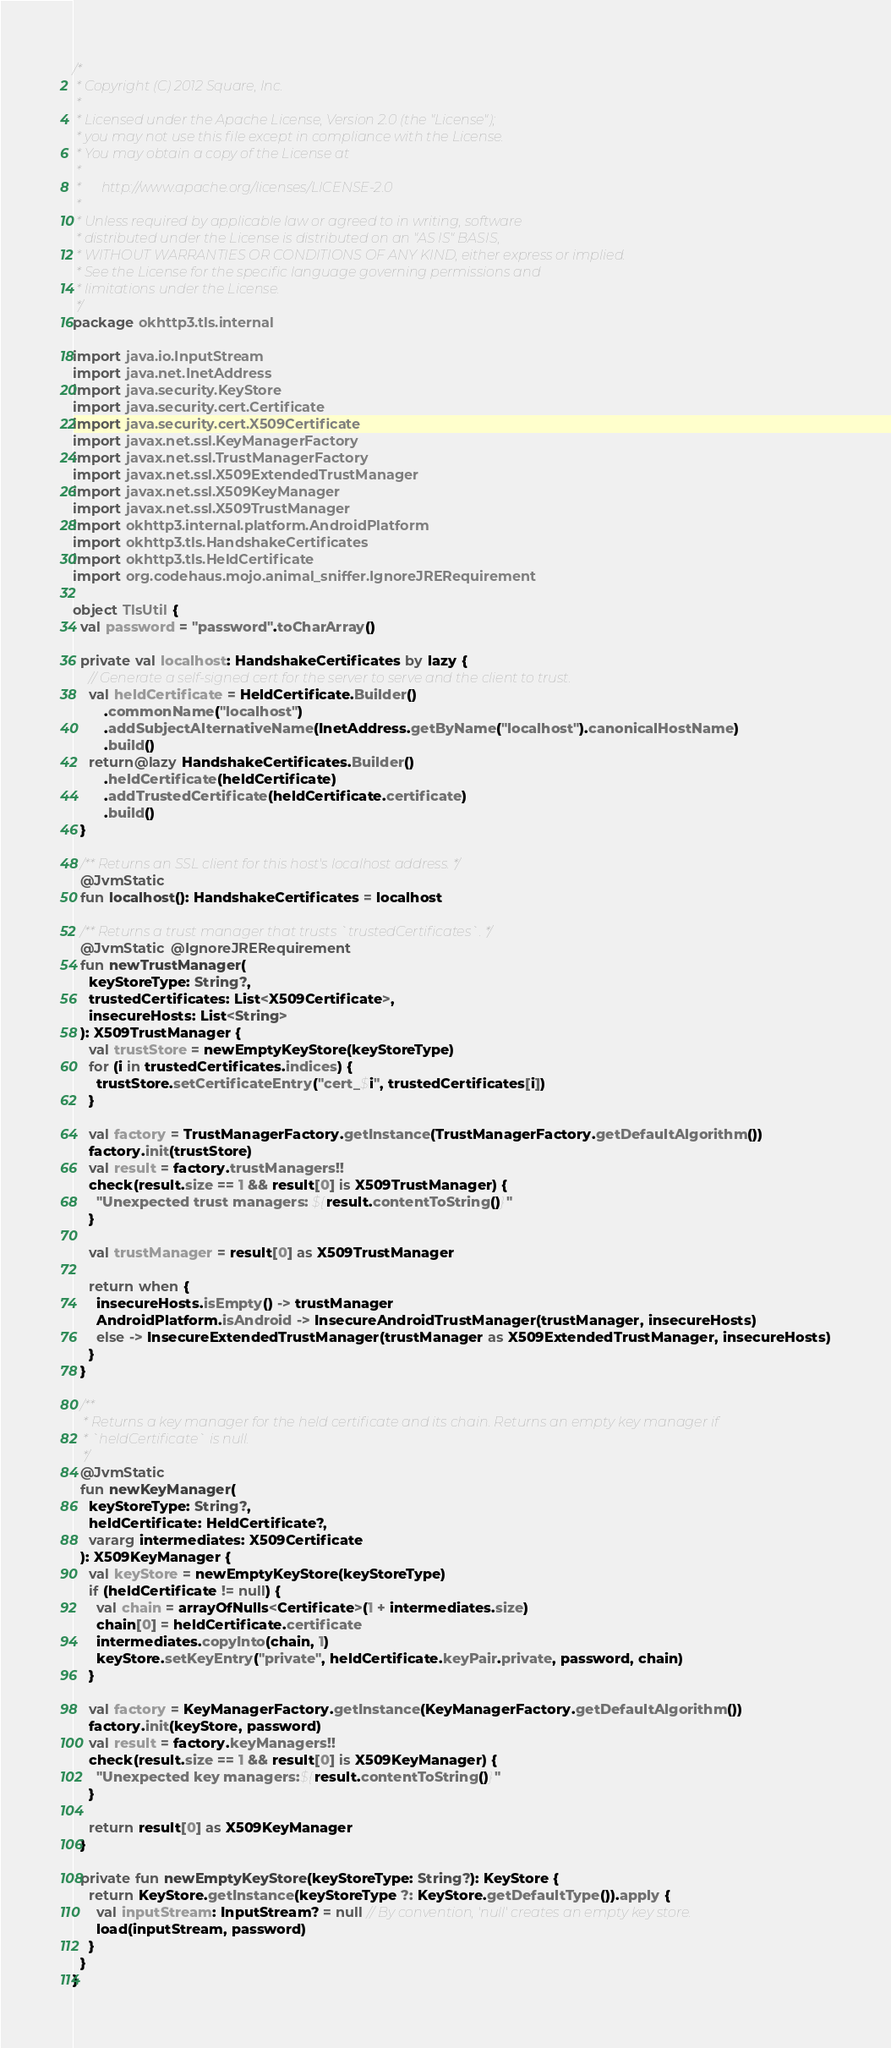<code> <loc_0><loc_0><loc_500><loc_500><_Kotlin_>/*
 * Copyright (C) 2012 Square, Inc.
 *
 * Licensed under the Apache License, Version 2.0 (the "License");
 * you may not use this file except in compliance with the License.
 * You may obtain a copy of the License at
 *
 *      http://www.apache.org/licenses/LICENSE-2.0
 *
 * Unless required by applicable law or agreed to in writing, software
 * distributed under the License is distributed on an "AS IS" BASIS,
 * WITHOUT WARRANTIES OR CONDITIONS OF ANY KIND, either express or implied.
 * See the License for the specific language governing permissions and
 * limitations under the License.
 */
package okhttp3.tls.internal

import java.io.InputStream
import java.net.InetAddress
import java.security.KeyStore
import java.security.cert.Certificate
import java.security.cert.X509Certificate
import javax.net.ssl.KeyManagerFactory
import javax.net.ssl.TrustManagerFactory
import javax.net.ssl.X509ExtendedTrustManager
import javax.net.ssl.X509KeyManager
import javax.net.ssl.X509TrustManager
import okhttp3.internal.platform.AndroidPlatform
import okhttp3.tls.HandshakeCertificates
import okhttp3.tls.HeldCertificate
import org.codehaus.mojo.animal_sniffer.IgnoreJRERequirement

object TlsUtil {
  val password = "password".toCharArray()

  private val localhost: HandshakeCertificates by lazy {
    // Generate a self-signed cert for the server to serve and the client to trust.
    val heldCertificate = HeldCertificate.Builder()
        .commonName("localhost")
        .addSubjectAlternativeName(InetAddress.getByName("localhost").canonicalHostName)
        .build()
    return@lazy HandshakeCertificates.Builder()
        .heldCertificate(heldCertificate)
        .addTrustedCertificate(heldCertificate.certificate)
        .build()
  }

  /** Returns an SSL client for this host's localhost address. */
  @JvmStatic
  fun localhost(): HandshakeCertificates = localhost

  /** Returns a trust manager that trusts `trustedCertificates`. */
  @JvmStatic @IgnoreJRERequirement
  fun newTrustManager(
    keyStoreType: String?,
    trustedCertificates: List<X509Certificate>,
    insecureHosts: List<String>
  ): X509TrustManager {
    val trustStore = newEmptyKeyStore(keyStoreType)
    for (i in trustedCertificates.indices) {
      trustStore.setCertificateEntry("cert_$i", trustedCertificates[i])
    }

    val factory = TrustManagerFactory.getInstance(TrustManagerFactory.getDefaultAlgorithm())
    factory.init(trustStore)
    val result = factory.trustManagers!!
    check(result.size == 1 && result[0] is X509TrustManager) {
      "Unexpected trust managers: ${result.contentToString()}"
    }

    val trustManager = result[0] as X509TrustManager

    return when {
      insecureHosts.isEmpty() -> trustManager
      AndroidPlatform.isAndroid -> InsecureAndroidTrustManager(trustManager, insecureHosts)
      else -> InsecureExtendedTrustManager(trustManager as X509ExtendedTrustManager, insecureHosts)
    }
  }

  /**
   * Returns a key manager for the held certificate and its chain. Returns an empty key manager if
   * `heldCertificate` is null.
   */
  @JvmStatic
  fun newKeyManager(
    keyStoreType: String?,
    heldCertificate: HeldCertificate?,
    vararg intermediates: X509Certificate
  ): X509KeyManager {
    val keyStore = newEmptyKeyStore(keyStoreType)
    if (heldCertificate != null) {
      val chain = arrayOfNulls<Certificate>(1 + intermediates.size)
      chain[0] = heldCertificate.certificate
      intermediates.copyInto(chain, 1)
      keyStore.setKeyEntry("private", heldCertificate.keyPair.private, password, chain)
    }

    val factory = KeyManagerFactory.getInstance(KeyManagerFactory.getDefaultAlgorithm())
    factory.init(keyStore, password)
    val result = factory.keyManagers!!
    check(result.size == 1 && result[0] is X509KeyManager) {
      "Unexpected key managers:${result.contentToString()}"
    }

    return result[0] as X509KeyManager
  }

  private fun newEmptyKeyStore(keyStoreType: String?): KeyStore {
    return KeyStore.getInstance(keyStoreType ?: KeyStore.getDefaultType()).apply {
      val inputStream: InputStream? = null // By convention, 'null' creates an empty key store.
      load(inputStream, password)
    }
  }
}
</code> 